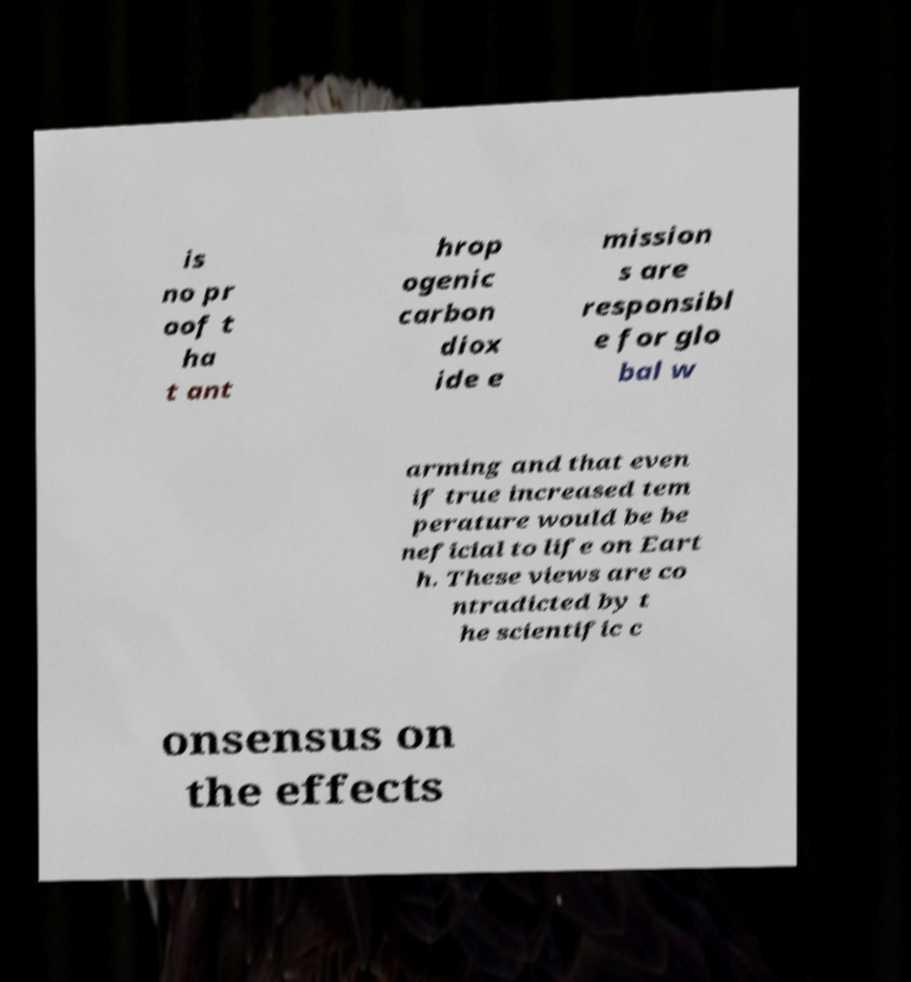For documentation purposes, I need the text within this image transcribed. Could you provide that? is no pr oof t ha t ant hrop ogenic carbon diox ide e mission s are responsibl e for glo bal w arming and that even if true increased tem perature would be be neficial to life on Eart h. These views are co ntradicted by t he scientific c onsensus on the effects 